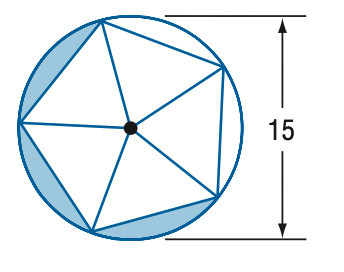Question: Find the area of the shaded region. Assume the inscribed polygon is regular.
Choices:
A. 8.6
B. 17.2
C. 25.8
D. 44.4
Answer with the letter. Answer: C 